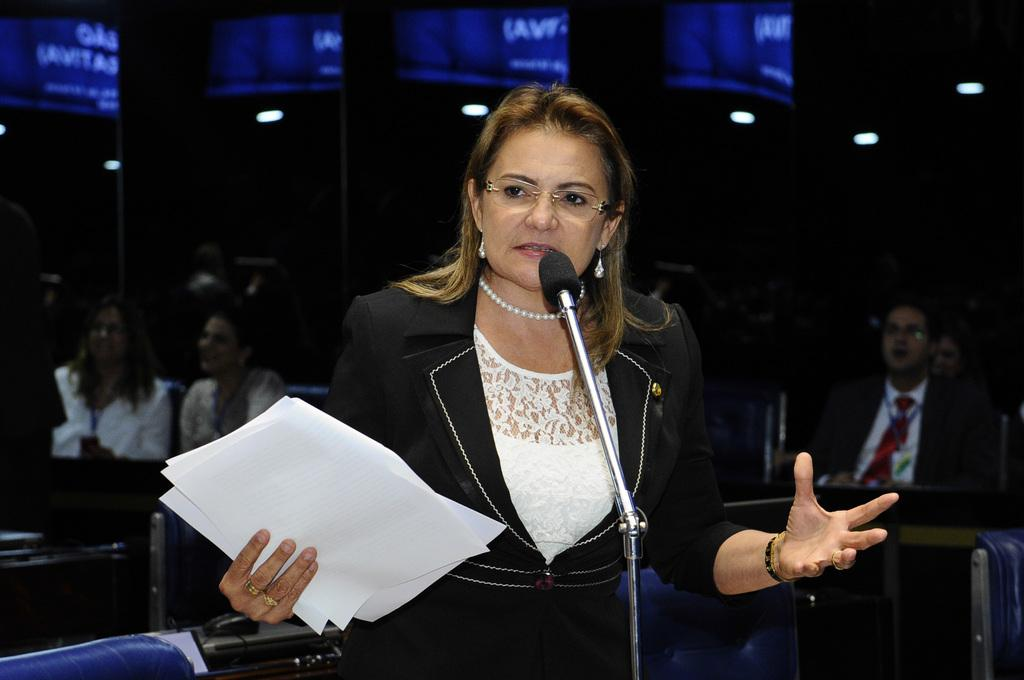What is the woman doing in the center of the image? The woman is standing at a microphone. What might the woman be using the microphone for? The woman might be using the microphone for speaking or singing. What else is the woman holding in the image? The woman has papers with her. What can be seen in the background of the image? There are people sitting in the background of the image. What type of steel is being used to transport wilderness in the image? There is no steel or wilderness present in the image; it features a woman standing at a microphone with papers and people sitting in the background. 